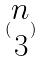<formula> <loc_0><loc_0><loc_500><loc_500>( \begin{matrix} n \\ 3 \end{matrix} )</formula> 